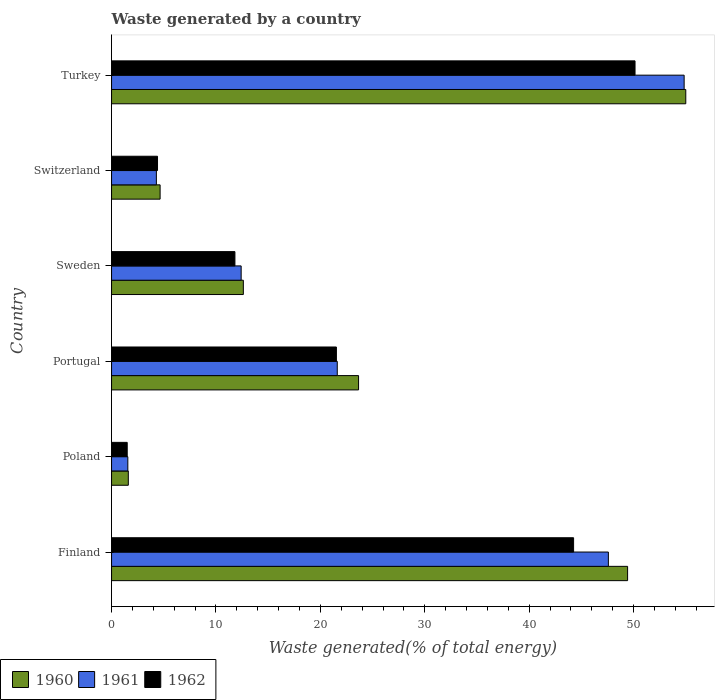How many different coloured bars are there?
Offer a very short reply. 3. How many groups of bars are there?
Your answer should be very brief. 6. Are the number of bars on each tick of the Y-axis equal?
Offer a very short reply. Yes. In how many cases, is the number of bars for a given country not equal to the number of legend labels?
Offer a terse response. 0. What is the total waste generated in 1962 in Finland?
Your answer should be compact. 44.25. Across all countries, what is the maximum total waste generated in 1960?
Make the answer very short. 54.99. Across all countries, what is the minimum total waste generated in 1961?
Your answer should be very brief. 1.56. In which country was the total waste generated in 1961 minimum?
Make the answer very short. Poland. What is the total total waste generated in 1961 in the graph?
Your answer should be compact. 142.3. What is the difference between the total waste generated in 1962 in Portugal and that in Switzerland?
Offer a very short reply. 17.13. What is the difference between the total waste generated in 1960 in Poland and the total waste generated in 1961 in Finland?
Give a very brief answer. -45.98. What is the average total waste generated in 1962 per country?
Offer a terse response. 22.27. What is the difference between the total waste generated in 1961 and total waste generated in 1962 in Finland?
Provide a succinct answer. 3.33. In how many countries, is the total waste generated in 1960 greater than 12 %?
Offer a terse response. 4. What is the ratio of the total waste generated in 1960 in Poland to that in Switzerland?
Make the answer very short. 0.35. What is the difference between the highest and the second highest total waste generated in 1960?
Your answer should be compact. 5.57. What is the difference between the highest and the lowest total waste generated in 1960?
Offer a terse response. 53.39. In how many countries, is the total waste generated in 1962 greater than the average total waste generated in 1962 taken over all countries?
Keep it short and to the point. 2. What does the 2nd bar from the top in Sweden represents?
Offer a terse response. 1961. What does the 1st bar from the bottom in Poland represents?
Provide a succinct answer. 1960. How many bars are there?
Keep it short and to the point. 18. How many countries are there in the graph?
Give a very brief answer. 6. What is the difference between two consecutive major ticks on the X-axis?
Your answer should be very brief. 10. Are the values on the major ticks of X-axis written in scientific E-notation?
Make the answer very short. No. Does the graph contain grids?
Provide a short and direct response. No. How are the legend labels stacked?
Your answer should be compact. Horizontal. What is the title of the graph?
Your response must be concise. Waste generated by a country. Does "1975" appear as one of the legend labels in the graph?
Provide a short and direct response. No. What is the label or title of the X-axis?
Ensure brevity in your answer.  Waste generated(% of total energy). What is the label or title of the Y-axis?
Your answer should be very brief. Country. What is the Waste generated(% of total energy) in 1960 in Finland?
Offer a very short reply. 49.42. What is the Waste generated(% of total energy) in 1961 in Finland?
Give a very brief answer. 47.58. What is the Waste generated(% of total energy) of 1962 in Finland?
Keep it short and to the point. 44.25. What is the Waste generated(% of total energy) in 1960 in Poland?
Provide a succinct answer. 1.6. What is the Waste generated(% of total energy) of 1961 in Poland?
Your answer should be compact. 1.56. What is the Waste generated(% of total energy) in 1962 in Poland?
Your answer should be compact. 1.5. What is the Waste generated(% of total energy) in 1960 in Portugal?
Offer a terse response. 23.66. What is the Waste generated(% of total energy) in 1961 in Portugal?
Your response must be concise. 21.62. What is the Waste generated(% of total energy) in 1962 in Portugal?
Your answer should be compact. 21.53. What is the Waste generated(% of total energy) in 1960 in Sweden?
Your response must be concise. 12.62. What is the Waste generated(% of total energy) in 1961 in Sweden?
Make the answer very short. 12.41. What is the Waste generated(% of total energy) in 1962 in Sweden?
Provide a short and direct response. 11.82. What is the Waste generated(% of total energy) in 1960 in Switzerland?
Give a very brief answer. 4.65. What is the Waste generated(% of total energy) of 1961 in Switzerland?
Offer a very short reply. 4.29. What is the Waste generated(% of total energy) of 1962 in Switzerland?
Make the answer very short. 4.4. What is the Waste generated(% of total energy) in 1960 in Turkey?
Provide a succinct answer. 54.99. What is the Waste generated(% of total energy) in 1961 in Turkey?
Your response must be concise. 54.84. What is the Waste generated(% of total energy) of 1962 in Turkey?
Give a very brief answer. 50.13. Across all countries, what is the maximum Waste generated(% of total energy) in 1960?
Your answer should be compact. 54.99. Across all countries, what is the maximum Waste generated(% of total energy) of 1961?
Give a very brief answer. 54.84. Across all countries, what is the maximum Waste generated(% of total energy) of 1962?
Keep it short and to the point. 50.13. Across all countries, what is the minimum Waste generated(% of total energy) in 1960?
Provide a succinct answer. 1.6. Across all countries, what is the minimum Waste generated(% of total energy) in 1961?
Give a very brief answer. 1.56. Across all countries, what is the minimum Waste generated(% of total energy) in 1962?
Offer a very short reply. 1.5. What is the total Waste generated(% of total energy) of 1960 in the graph?
Keep it short and to the point. 146.95. What is the total Waste generated(% of total energy) in 1961 in the graph?
Offer a terse response. 142.3. What is the total Waste generated(% of total energy) in 1962 in the graph?
Ensure brevity in your answer.  133.64. What is the difference between the Waste generated(% of total energy) in 1960 in Finland and that in Poland?
Your response must be concise. 47.82. What is the difference between the Waste generated(% of total energy) of 1961 in Finland and that in Poland?
Make the answer very short. 46.02. What is the difference between the Waste generated(% of total energy) of 1962 in Finland and that in Poland?
Offer a very short reply. 42.75. What is the difference between the Waste generated(% of total energy) of 1960 in Finland and that in Portugal?
Your answer should be very brief. 25.77. What is the difference between the Waste generated(% of total energy) in 1961 in Finland and that in Portugal?
Offer a terse response. 25.96. What is the difference between the Waste generated(% of total energy) in 1962 in Finland and that in Portugal?
Your answer should be very brief. 22.72. What is the difference between the Waste generated(% of total energy) in 1960 in Finland and that in Sweden?
Provide a succinct answer. 36.8. What is the difference between the Waste generated(% of total energy) of 1961 in Finland and that in Sweden?
Your response must be concise. 35.17. What is the difference between the Waste generated(% of total energy) of 1962 in Finland and that in Sweden?
Offer a terse response. 32.44. What is the difference between the Waste generated(% of total energy) in 1960 in Finland and that in Switzerland?
Keep it short and to the point. 44.77. What is the difference between the Waste generated(% of total energy) of 1961 in Finland and that in Switzerland?
Provide a short and direct response. 43.29. What is the difference between the Waste generated(% of total energy) of 1962 in Finland and that in Switzerland?
Offer a very short reply. 39.85. What is the difference between the Waste generated(% of total energy) of 1960 in Finland and that in Turkey?
Your response must be concise. -5.57. What is the difference between the Waste generated(% of total energy) in 1961 in Finland and that in Turkey?
Offer a terse response. -7.26. What is the difference between the Waste generated(% of total energy) of 1962 in Finland and that in Turkey?
Keep it short and to the point. -5.88. What is the difference between the Waste generated(% of total energy) of 1960 in Poland and that in Portugal?
Your answer should be very brief. -22.05. What is the difference between the Waste generated(% of total energy) of 1961 in Poland and that in Portugal?
Ensure brevity in your answer.  -20.06. What is the difference between the Waste generated(% of total energy) in 1962 in Poland and that in Portugal?
Keep it short and to the point. -20.03. What is the difference between the Waste generated(% of total energy) of 1960 in Poland and that in Sweden?
Provide a succinct answer. -11.02. What is the difference between the Waste generated(% of total energy) of 1961 in Poland and that in Sweden?
Provide a succinct answer. -10.85. What is the difference between the Waste generated(% of total energy) of 1962 in Poland and that in Sweden?
Your answer should be compact. -10.32. What is the difference between the Waste generated(% of total energy) in 1960 in Poland and that in Switzerland?
Provide a succinct answer. -3.04. What is the difference between the Waste generated(% of total energy) of 1961 in Poland and that in Switzerland?
Keep it short and to the point. -2.73. What is the difference between the Waste generated(% of total energy) in 1962 in Poland and that in Switzerland?
Provide a succinct answer. -2.9. What is the difference between the Waste generated(% of total energy) of 1960 in Poland and that in Turkey?
Provide a succinct answer. -53.39. What is the difference between the Waste generated(% of total energy) of 1961 in Poland and that in Turkey?
Your answer should be very brief. -53.28. What is the difference between the Waste generated(% of total energy) in 1962 in Poland and that in Turkey?
Provide a succinct answer. -48.64. What is the difference between the Waste generated(% of total energy) in 1960 in Portugal and that in Sweden?
Keep it short and to the point. 11.03. What is the difference between the Waste generated(% of total energy) in 1961 in Portugal and that in Sweden?
Provide a succinct answer. 9.2. What is the difference between the Waste generated(% of total energy) in 1962 in Portugal and that in Sweden?
Your response must be concise. 9.72. What is the difference between the Waste generated(% of total energy) in 1960 in Portugal and that in Switzerland?
Your response must be concise. 19.01. What is the difference between the Waste generated(% of total energy) of 1961 in Portugal and that in Switzerland?
Your answer should be very brief. 17.32. What is the difference between the Waste generated(% of total energy) in 1962 in Portugal and that in Switzerland?
Give a very brief answer. 17.13. What is the difference between the Waste generated(% of total energy) of 1960 in Portugal and that in Turkey?
Your answer should be very brief. -31.34. What is the difference between the Waste generated(% of total energy) of 1961 in Portugal and that in Turkey?
Offer a terse response. -33.22. What is the difference between the Waste generated(% of total energy) of 1962 in Portugal and that in Turkey?
Ensure brevity in your answer.  -28.6. What is the difference between the Waste generated(% of total energy) of 1960 in Sweden and that in Switzerland?
Offer a very short reply. 7.97. What is the difference between the Waste generated(% of total energy) in 1961 in Sweden and that in Switzerland?
Your response must be concise. 8.12. What is the difference between the Waste generated(% of total energy) of 1962 in Sweden and that in Switzerland?
Offer a terse response. 7.41. What is the difference between the Waste generated(% of total energy) of 1960 in Sweden and that in Turkey?
Ensure brevity in your answer.  -42.37. What is the difference between the Waste generated(% of total energy) of 1961 in Sweden and that in Turkey?
Offer a very short reply. -42.43. What is the difference between the Waste generated(% of total energy) of 1962 in Sweden and that in Turkey?
Offer a very short reply. -38.32. What is the difference between the Waste generated(% of total energy) of 1960 in Switzerland and that in Turkey?
Make the answer very short. -50.34. What is the difference between the Waste generated(% of total energy) of 1961 in Switzerland and that in Turkey?
Make the answer very short. -50.55. What is the difference between the Waste generated(% of total energy) in 1962 in Switzerland and that in Turkey?
Ensure brevity in your answer.  -45.73. What is the difference between the Waste generated(% of total energy) in 1960 in Finland and the Waste generated(% of total energy) in 1961 in Poland?
Offer a very short reply. 47.86. What is the difference between the Waste generated(% of total energy) in 1960 in Finland and the Waste generated(% of total energy) in 1962 in Poland?
Give a very brief answer. 47.92. What is the difference between the Waste generated(% of total energy) of 1961 in Finland and the Waste generated(% of total energy) of 1962 in Poland?
Offer a terse response. 46.08. What is the difference between the Waste generated(% of total energy) in 1960 in Finland and the Waste generated(% of total energy) in 1961 in Portugal?
Your answer should be compact. 27.81. What is the difference between the Waste generated(% of total energy) of 1960 in Finland and the Waste generated(% of total energy) of 1962 in Portugal?
Your response must be concise. 27.89. What is the difference between the Waste generated(% of total energy) in 1961 in Finland and the Waste generated(% of total energy) in 1962 in Portugal?
Your answer should be compact. 26.05. What is the difference between the Waste generated(% of total energy) in 1960 in Finland and the Waste generated(% of total energy) in 1961 in Sweden?
Provide a short and direct response. 37.01. What is the difference between the Waste generated(% of total energy) of 1960 in Finland and the Waste generated(% of total energy) of 1962 in Sweden?
Your answer should be compact. 37.61. What is the difference between the Waste generated(% of total energy) in 1961 in Finland and the Waste generated(% of total energy) in 1962 in Sweden?
Ensure brevity in your answer.  35.77. What is the difference between the Waste generated(% of total energy) in 1960 in Finland and the Waste generated(% of total energy) in 1961 in Switzerland?
Keep it short and to the point. 45.13. What is the difference between the Waste generated(% of total energy) of 1960 in Finland and the Waste generated(% of total energy) of 1962 in Switzerland?
Ensure brevity in your answer.  45.02. What is the difference between the Waste generated(% of total energy) in 1961 in Finland and the Waste generated(% of total energy) in 1962 in Switzerland?
Give a very brief answer. 43.18. What is the difference between the Waste generated(% of total energy) of 1960 in Finland and the Waste generated(% of total energy) of 1961 in Turkey?
Give a very brief answer. -5.42. What is the difference between the Waste generated(% of total energy) of 1960 in Finland and the Waste generated(% of total energy) of 1962 in Turkey?
Your answer should be very brief. -0.71. What is the difference between the Waste generated(% of total energy) in 1961 in Finland and the Waste generated(% of total energy) in 1962 in Turkey?
Keep it short and to the point. -2.55. What is the difference between the Waste generated(% of total energy) in 1960 in Poland and the Waste generated(% of total energy) in 1961 in Portugal?
Your answer should be compact. -20.01. What is the difference between the Waste generated(% of total energy) in 1960 in Poland and the Waste generated(% of total energy) in 1962 in Portugal?
Give a very brief answer. -19.93. What is the difference between the Waste generated(% of total energy) in 1961 in Poland and the Waste generated(% of total energy) in 1962 in Portugal?
Offer a terse response. -19.98. What is the difference between the Waste generated(% of total energy) of 1960 in Poland and the Waste generated(% of total energy) of 1961 in Sweden?
Your answer should be compact. -10.81. What is the difference between the Waste generated(% of total energy) in 1960 in Poland and the Waste generated(% of total energy) in 1962 in Sweden?
Your response must be concise. -10.21. What is the difference between the Waste generated(% of total energy) in 1961 in Poland and the Waste generated(% of total energy) in 1962 in Sweden?
Provide a short and direct response. -10.26. What is the difference between the Waste generated(% of total energy) of 1960 in Poland and the Waste generated(% of total energy) of 1961 in Switzerland?
Offer a terse response. -2.69. What is the difference between the Waste generated(% of total energy) in 1960 in Poland and the Waste generated(% of total energy) in 1962 in Switzerland?
Your answer should be very brief. -2.8. What is the difference between the Waste generated(% of total energy) in 1961 in Poland and the Waste generated(% of total energy) in 1962 in Switzerland?
Make the answer very short. -2.84. What is the difference between the Waste generated(% of total energy) of 1960 in Poland and the Waste generated(% of total energy) of 1961 in Turkey?
Ensure brevity in your answer.  -53.23. What is the difference between the Waste generated(% of total energy) of 1960 in Poland and the Waste generated(% of total energy) of 1962 in Turkey?
Give a very brief answer. -48.53. What is the difference between the Waste generated(% of total energy) of 1961 in Poland and the Waste generated(% of total energy) of 1962 in Turkey?
Provide a short and direct response. -48.58. What is the difference between the Waste generated(% of total energy) of 1960 in Portugal and the Waste generated(% of total energy) of 1961 in Sweden?
Offer a very short reply. 11.24. What is the difference between the Waste generated(% of total energy) in 1960 in Portugal and the Waste generated(% of total energy) in 1962 in Sweden?
Your response must be concise. 11.84. What is the difference between the Waste generated(% of total energy) in 1961 in Portugal and the Waste generated(% of total energy) in 1962 in Sweden?
Give a very brief answer. 9.8. What is the difference between the Waste generated(% of total energy) in 1960 in Portugal and the Waste generated(% of total energy) in 1961 in Switzerland?
Offer a terse response. 19.36. What is the difference between the Waste generated(% of total energy) of 1960 in Portugal and the Waste generated(% of total energy) of 1962 in Switzerland?
Your answer should be very brief. 19.25. What is the difference between the Waste generated(% of total energy) in 1961 in Portugal and the Waste generated(% of total energy) in 1962 in Switzerland?
Keep it short and to the point. 17.21. What is the difference between the Waste generated(% of total energy) of 1960 in Portugal and the Waste generated(% of total energy) of 1961 in Turkey?
Make the answer very short. -31.18. What is the difference between the Waste generated(% of total energy) in 1960 in Portugal and the Waste generated(% of total energy) in 1962 in Turkey?
Keep it short and to the point. -26.48. What is the difference between the Waste generated(% of total energy) in 1961 in Portugal and the Waste generated(% of total energy) in 1962 in Turkey?
Offer a very short reply. -28.52. What is the difference between the Waste generated(% of total energy) in 1960 in Sweden and the Waste generated(% of total energy) in 1961 in Switzerland?
Offer a very short reply. 8.33. What is the difference between the Waste generated(% of total energy) in 1960 in Sweden and the Waste generated(% of total energy) in 1962 in Switzerland?
Provide a succinct answer. 8.22. What is the difference between the Waste generated(% of total energy) in 1961 in Sweden and the Waste generated(% of total energy) in 1962 in Switzerland?
Ensure brevity in your answer.  8.01. What is the difference between the Waste generated(% of total energy) in 1960 in Sweden and the Waste generated(% of total energy) in 1961 in Turkey?
Your answer should be very brief. -42.22. What is the difference between the Waste generated(% of total energy) in 1960 in Sweden and the Waste generated(% of total energy) in 1962 in Turkey?
Provide a succinct answer. -37.51. What is the difference between the Waste generated(% of total energy) of 1961 in Sweden and the Waste generated(% of total energy) of 1962 in Turkey?
Make the answer very short. -37.72. What is the difference between the Waste generated(% of total energy) in 1960 in Switzerland and the Waste generated(% of total energy) in 1961 in Turkey?
Offer a terse response. -50.19. What is the difference between the Waste generated(% of total energy) of 1960 in Switzerland and the Waste generated(% of total energy) of 1962 in Turkey?
Give a very brief answer. -45.48. What is the difference between the Waste generated(% of total energy) in 1961 in Switzerland and the Waste generated(% of total energy) in 1962 in Turkey?
Give a very brief answer. -45.84. What is the average Waste generated(% of total energy) of 1960 per country?
Keep it short and to the point. 24.49. What is the average Waste generated(% of total energy) of 1961 per country?
Offer a terse response. 23.72. What is the average Waste generated(% of total energy) in 1962 per country?
Your answer should be compact. 22.27. What is the difference between the Waste generated(% of total energy) of 1960 and Waste generated(% of total energy) of 1961 in Finland?
Make the answer very short. 1.84. What is the difference between the Waste generated(% of total energy) in 1960 and Waste generated(% of total energy) in 1962 in Finland?
Your answer should be very brief. 5.17. What is the difference between the Waste generated(% of total energy) in 1961 and Waste generated(% of total energy) in 1962 in Finland?
Keep it short and to the point. 3.33. What is the difference between the Waste generated(% of total energy) of 1960 and Waste generated(% of total energy) of 1961 in Poland?
Offer a terse response. 0.05. What is the difference between the Waste generated(% of total energy) in 1960 and Waste generated(% of total energy) in 1962 in Poland?
Provide a succinct answer. 0.11. What is the difference between the Waste generated(% of total energy) in 1961 and Waste generated(% of total energy) in 1962 in Poland?
Your answer should be very brief. 0.06. What is the difference between the Waste generated(% of total energy) of 1960 and Waste generated(% of total energy) of 1961 in Portugal?
Make the answer very short. 2.04. What is the difference between the Waste generated(% of total energy) of 1960 and Waste generated(% of total energy) of 1962 in Portugal?
Make the answer very short. 2.12. What is the difference between the Waste generated(% of total energy) of 1961 and Waste generated(% of total energy) of 1962 in Portugal?
Provide a short and direct response. 0.08. What is the difference between the Waste generated(% of total energy) of 1960 and Waste generated(% of total energy) of 1961 in Sweden?
Offer a very short reply. 0.21. What is the difference between the Waste generated(% of total energy) of 1960 and Waste generated(% of total energy) of 1962 in Sweden?
Give a very brief answer. 0.81. What is the difference between the Waste generated(% of total energy) in 1961 and Waste generated(% of total energy) in 1962 in Sweden?
Offer a terse response. 0.6. What is the difference between the Waste generated(% of total energy) of 1960 and Waste generated(% of total energy) of 1961 in Switzerland?
Provide a succinct answer. 0.36. What is the difference between the Waste generated(% of total energy) in 1960 and Waste generated(% of total energy) in 1962 in Switzerland?
Offer a terse response. 0.25. What is the difference between the Waste generated(% of total energy) of 1961 and Waste generated(% of total energy) of 1962 in Switzerland?
Make the answer very short. -0.11. What is the difference between the Waste generated(% of total energy) in 1960 and Waste generated(% of total energy) in 1961 in Turkey?
Make the answer very short. 0.16. What is the difference between the Waste generated(% of total energy) in 1960 and Waste generated(% of total energy) in 1962 in Turkey?
Offer a terse response. 4.86. What is the difference between the Waste generated(% of total energy) in 1961 and Waste generated(% of total energy) in 1962 in Turkey?
Make the answer very short. 4.7. What is the ratio of the Waste generated(% of total energy) of 1960 in Finland to that in Poland?
Your answer should be very brief. 30.8. What is the ratio of the Waste generated(% of total energy) of 1961 in Finland to that in Poland?
Your answer should be compact. 30.53. What is the ratio of the Waste generated(% of total energy) in 1962 in Finland to that in Poland?
Your answer should be very brief. 29.52. What is the ratio of the Waste generated(% of total energy) in 1960 in Finland to that in Portugal?
Make the answer very short. 2.09. What is the ratio of the Waste generated(% of total energy) of 1961 in Finland to that in Portugal?
Your response must be concise. 2.2. What is the ratio of the Waste generated(% of total energy) of 1962 in Finland to that in Portugal?
Offer a terse response. 2.05. What is the ratio of the Waste generated(% of total energy) of 1960 in Finland to that in Sweden?
Offer a very short reply. 3.92. What is the ratio of the Waste generated(% of total energy) in 1961 in Finland to that in Sweden?
Make the answer very short. 3.83. What is the ratio of the Waste generated(% of total energy) in 1962 in Finland to that in Sweden?
Provide a short and direct response. 3.75. What is the ratio of the Waste generated(% of total energy) of 1960 in Finland to that in Switzerland?
Offer a very short reply. 10.63. What is the ratio of the Waste generated(% of total energy) in 1961 in Finland to that in Switzerland?
Make the answer very short. 11.09. What is the ratio of the Waste generated(% of total energy) of 1962 in Finland to that in Switzerland?
Ensure brevity in your answer.  10.05. What is the ratio of the Waste generated(% of total energy) in 1960 in Finland to that in Turkey?
Your response must be concise. 0.9. What is the ratio of the Waste generated(% of total energy) of 1961 in Finland to that in Turkey?
Your answer should be very brief. 0.87. What is the ratio of the Waste generated(% of total energy) in 1962 in Finland to that in Turkey?
Offer a very short reply. 0.88. What is the ratio of the Waste generated(% of total energy) of 1960 in Poland to that in Portugal?
Give a very brief answer. 0.07. What is the ratio of the Waste generated(% of total energy) in 1961 in Poland to that in Portugal?
Your response must be concise. 0.07. What is the ratio of the Waste generated(% of total energy) in 1962 in Poland to that in Portugal?
Keep it short and to the point. 0.07. What is the ratio of the Waste generated(% of total energy) in 1960 in Poland to that in Sweden?
Provide a short and direct response. 0.13. What is the ratio of the Waste generated(% of total energy) of 1961 in Poland to that in Sweden?
Give a very brief answer. 0.13. What is the ratio of the Waste generated(% of total energy) of 1962 in Poland to that in Sweden?
Keep it short and to the point. 0.13. What is the ratio of the Waste generated(% of total energy) in 1960 in Poland to that in Switzerland?
Make the answer very short. 0.35. What is the ratio of the Waste generated(% of total energy) of 1961 in Poland to that in Switzerland?
Offer a very short reply. 0.36. What is the ratio of the Waste generated(% of total energy) in 1962 in Poland to that in Switzerland?
Your answer should be very brief. 0.34. What is the ratio of the Waste generated(% of total energy) in 1960 in Poland to that in Turkey?
Give a very brief answer. 0.03. What is the ratio of the Waste generated(% of total energy) in 1961 in Poland to that in Turkey?
Ensure brevity in your answer.  0.03. What is the ratio of the Waste generated(% of total energy) of 1962 in Poland to that in Turkey?
Keep it short and to the point. 0.03. What is the ratio of the Waste generated(% of total energy) in 1960 in Portugal to that in Sweden?
Your answer should be compact. 1.87. What is the ratio of the Waste generated(% of total energy) in 1961 in Portugal to that in Sweden?
Ensure brevity in your answer.  1.74. What is the ratio of the Waste generated(% of total energy) of 1962 in Portugal to that in Sweden?
Give a very brief answer. 1.82. What is the ratio of the Waste generated(% of total energy) of 1960 in Portugal to that in Switzerland?
Provide a short and direct response. 5.09. What is the ratio of the Waste generated(% of total energy) in 1961 in Portugal to that in Switzerland?
Your response must be concise. 5.04. What is the ratio of the Waste generated(% of total energy) in 1962 in Portugal to that in Switzerland?
Make the answer very short. 4.89. What is the ratio of the Waste generated(% of total energy) of 1960 in Portugal to that in Turkey?
Provide a short and direct response. 0.43. What is the ratio of the Waste generated(% of total energy) of 1961 in Portugal to that in Turkey?
Provide a short and direct response. 0.39. What is the ratio of the Waste generated(% of total energy) in 1962 in Portugal to that in Turkey?
Your response must be concise. 0.43. What is the ratio of the Waste generated(% of total energy) in 1960 in Sweden to that in Switzerland?
Provide a succinct answer. 2.71. What is the ratio of the Waste generated(% of total energy) in 1961 in Sweden to that in Switzerland?
Give a very brief answer. 2.89. What is the ratio of the Waste generated(% of total energy) in 1962 in Sweden to that in Switzerland?
Make the answer very short. 2.68. What is the ratio of the Waste generated(% of total energy) of 1960 in Sweden to that in Turkey?
Provide a short and direct response. 0.23. What is the ratio of the Waste generated(% of total energy) in 1961 in Sweden to that in Turkey?
Offer a very short reply. 0.23. What is the ratio of the Waste generated(% of total energy) in 1962 in Sweden to that in Turkey?
Provide a succinct answer. 0.24. What is the ratio of the Waste generated(% of total energy) of 1960 in Switzerland to that in Turkey?
Offer a very short reply. 0.08. What is the ratio of the Waste generated(% of total energy) of 1961 in Switzerland to that in Turkey?
Your answer should be very brief. 0.08. What is the ratio of the Waste generated(% of total energy) of 1962 in Switzerland to that in Turkey?
Make the answer very short. 0.09. What is the difference between the highest and the second highest Waste generated(% of total energy) in 1960?
Provide a succinct answer. 5.57. What is the difference between the highest and the second highest Waste generated(% of total energy) of 1961?
Provide a succinct answer. 7.26. What is the difference between the highest and the second highest Waste generated(% of total energy) in 1962?
Make the answer very short. 5.88. What is the difference between the highest and the lowest Waste generated(% of total energy) of 1960?
Ensure brevity in your answer.  53.39. What is the difference between the highest and the lowest Waste generated(% of total energy) of 1961?
Your answer should be very brief. 53.28. What is the difference between the highest and the lowest Waste generated(% of total energy) in 1962?
Give a very brief answer. 48.64. 